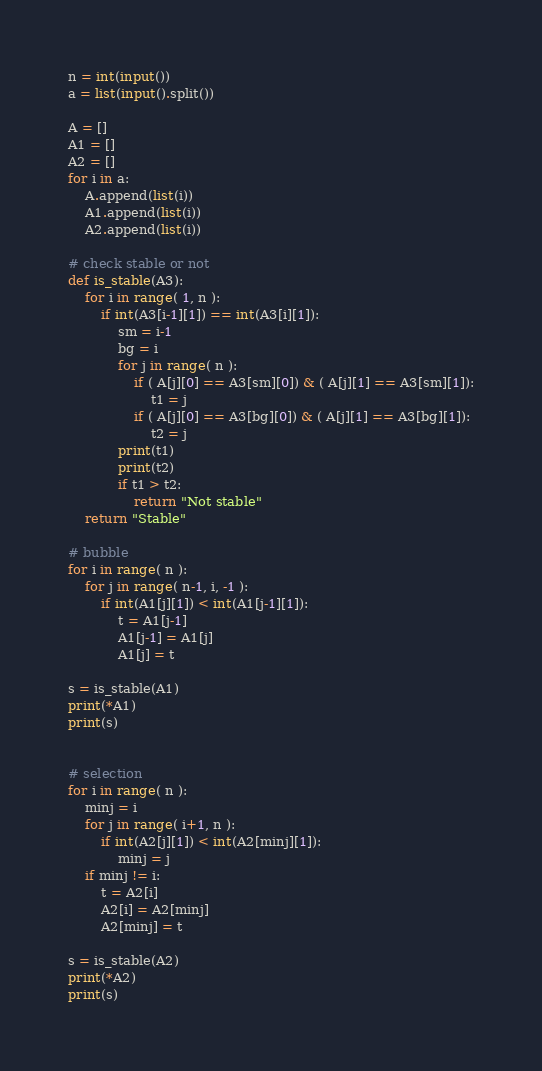Convert code to text. <code><loc_0><loc_0><loc_500><loc_500><_Python_>n = int(input())
a = list(input().split())

A = []
A1 = []
A2 = []
for i in a:
    A.append(list(i))
    A1.append(list(i))
    A2.append(list(i))

# check stable or not
def is_stable(A3):
    for i in range( 1, n ):
        if int(A3[i-1][1]) == int(A3[i][1]):
            sm = i-1
            bg = i
            for j in range( n ):
                if ( A[j][0] == A3[sm][0]) & ( A[j][1] == A3[sm][1]):
                    t1 = j
                if ( A[j][0] == A3[bg][0]) & ( A[j][1] == A3[bg][1]):
                    t2 = j
            print(t1)
            print(t2)
            if t1 > t2:
                return "Not stable"
    return "Stable"

# bubble
for i in range( n ):
    for j in range( n-1, i, -1 ):
        if int(A1[j][1]) < int(A1[j-1][1]):
            t = A1[j-1]
            A1[j-1] = A1[j]
            A1[j] = t

s = is_stable(A1)
print(*A1)
print(s)


# selection
for i in range( n ):
    minj = i
    for j in range( i+1, n ):
        if int(A2[j][1]) < int(A2[minj][1]):
            minj = j
    if minj != i:
        t = A2[i]
        A2[i] = A2[minj]
        A2[minj] = t

s = is_stable(A2)
print(*A2)
print(s)</code> 